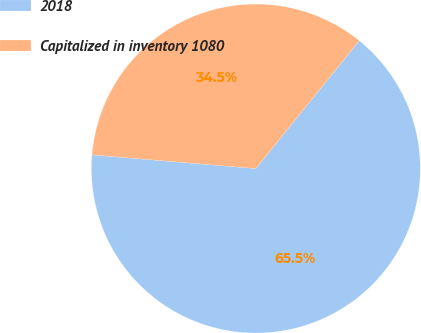Convert chart. <chart><loc_0><loc_0><loc_500><loc_500><pie_chart><fcel>2018<fcel>Capitalized in inventory 1080<nl><fcel>65.51%<fcel>34.49%<nl></chart> 